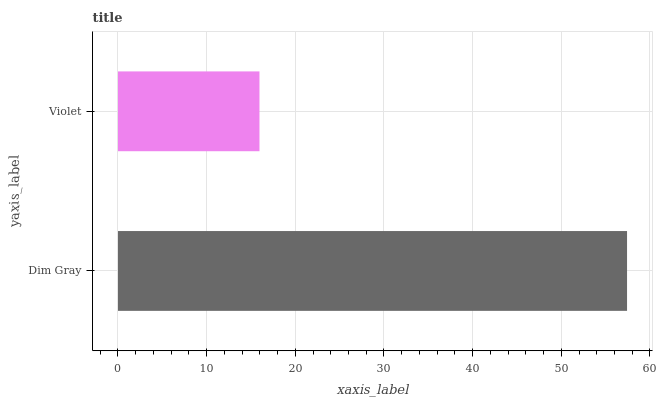Is Violet the minimum?
Answer yes or no. Yes. Is Dim Gray the maximum?
Answer yes or no. Yes. Is Violet the maximum?
Answer yes or no. No. Is Dim Gray greater than Violet?
Answer yes or no. Yes. Is Violet less than Dim Gray?
Answer yes or no. Yes. Is Violet greater than Dim Gray?
Answer yes or no. No. Is Dim Gray less than Violet?
Answer yes or no. No. Is Dim Gray the high median?
Answer yes or no. Yes. Is Violet the low median?
Answer yes or no. Yes. Is Violet the high median?
Answer yes or no. No. Is Dim Gray the low median?
Answer yes or no. No. 